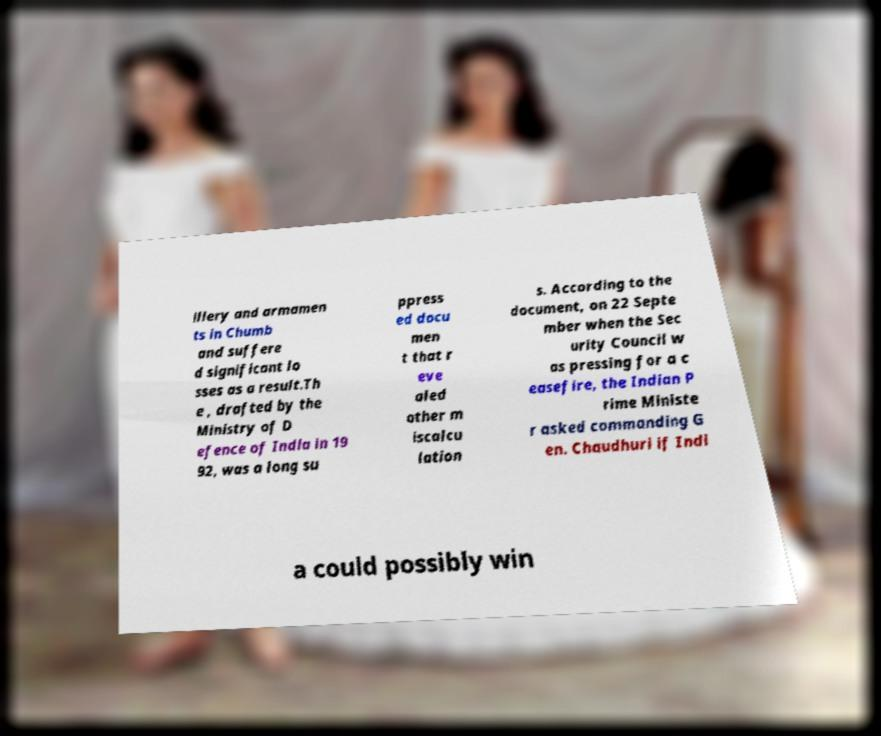Can you read and provide the text displayed in the image?This photo seems to have some interesting text. Can you extract and type it out for me? illery and armamen ts in Chumb and suffere d significant lo sses as a result.Th e , drafted by the Ministry of D efence of India in 19 92, was a long su ppress ed docu men t that r eve aled other m iscalcu lation s. According to the document, on 22 Septe mber when the Sec urity Council w as pressing for a c easefire, the Indian P rime Ministe r asked commanding G en. Chaudhuri if Indi a could possibly win 